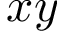Convert formula to latex. <formula><loc_0><loc_0><loc_500><loc_500>x y</formula> 